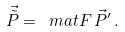<formula> <loc_0><loc_0><loc_500><loc_500>\vec { \tilde { P } } = \ m a t F \, \vec { P } ^ { \prime } \, .</formula> 